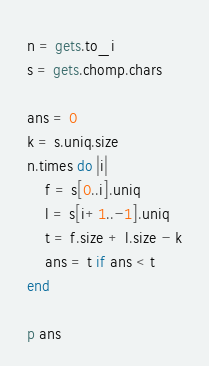<code> <loc_0><loc_0><loc_500><loc_500><_Ruby_>n = gets.to_i
s = gets.chomp.chars

ans = 0
k = s.uniq.size
n.times do |i|
    f = s[0..i].uniq
    l = s[i+1..-1].uniq
    t = f.size + l.size - k
    ans = t if ans < t
end

p ans</code> 